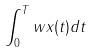Convert formula to latex. <formula><loc_0><loc_0><loc_500><loc_500>\int _ { 0 } ^ { T } w x ( t ) d t</formula> 